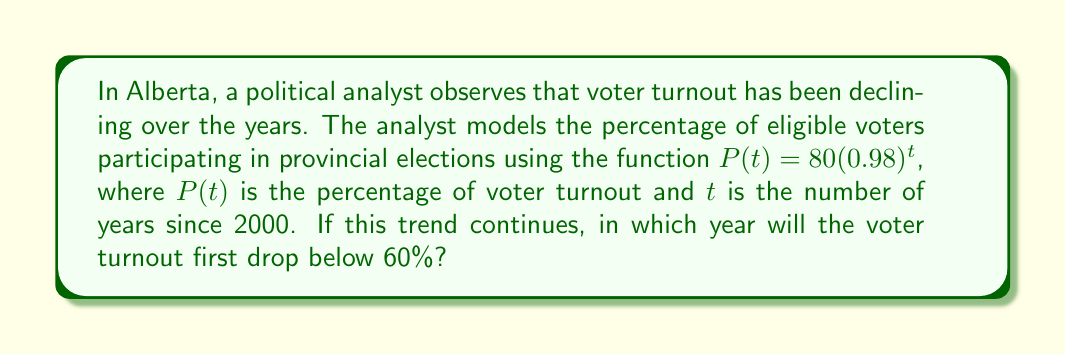Teach me how to tackle this problem. To solve this problem, we need to follow these steps:

1) We want to find when $P(t) < 60\%$. So, we set up the inequality:
   $80(0.98)^t < 60$

2) Divide both sides by 80:
   $(0.98)^t < \frac{60}{80} = 0.75$

3) Take the natural log of both sides:
   $t \ln(0.98) < \ln(0.75)$

4) Divide both sides by $\ln(0.98)$ (note that this flips the inequality because $\ln(0.98)$ is negative):
   $t > \frac{\ln(0.75)}{\ln(0.98)} \approx 14.0843$

5) Since $t$ represents the number of years since 2000, and we need the first year it drops below 60%, we round up to the next whole number:
   $t = 15$

6) Add this to 2000 to get the actual year:
   $2000 + 15 = 2015$

Therefore, if this trend continues, voter turnout will first drop below 60% in 2015.
Answer: 2015 